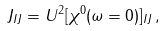Convert formula to latex. <formula><loc_0><loc_0><loc_500><loc_500>J _ { I J } = U ^ { 2 } [ \chi ^ { 0 } ( \omega = 0 ) ] _ { I J } \, ,</formula> 